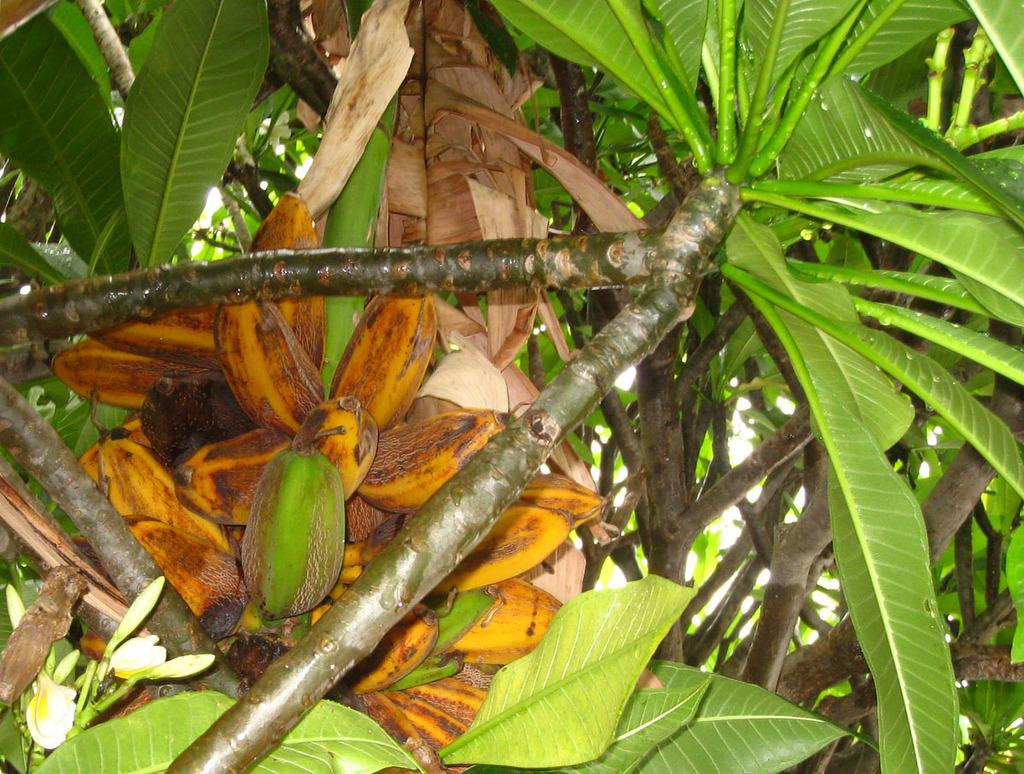What type of objects can be seen in the tree in the image? There are fruits in the tree in the image. Can you see any tubs or screws attached to the tree in the image? No, there are no tubs or screws present in the image; it only features a tree with fruits. 